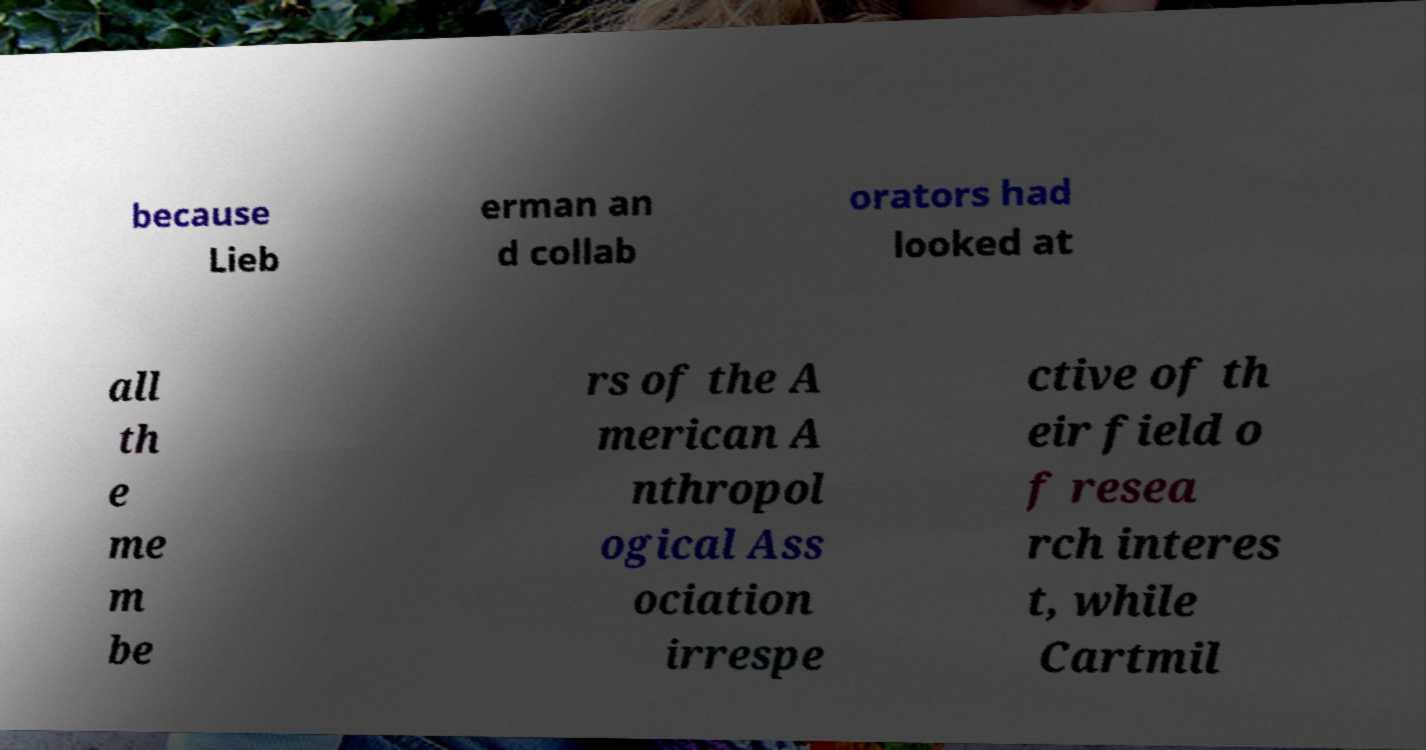For documentation purposes, I need the text within this image transcribed. Could you provide that? because Lieb erman an d collab orators had looked at all th e me m be rs of the A merican A nthropol ogical Ass ociation irrespe ctive of th eir field o f resea rch interes t, while Cartmil 